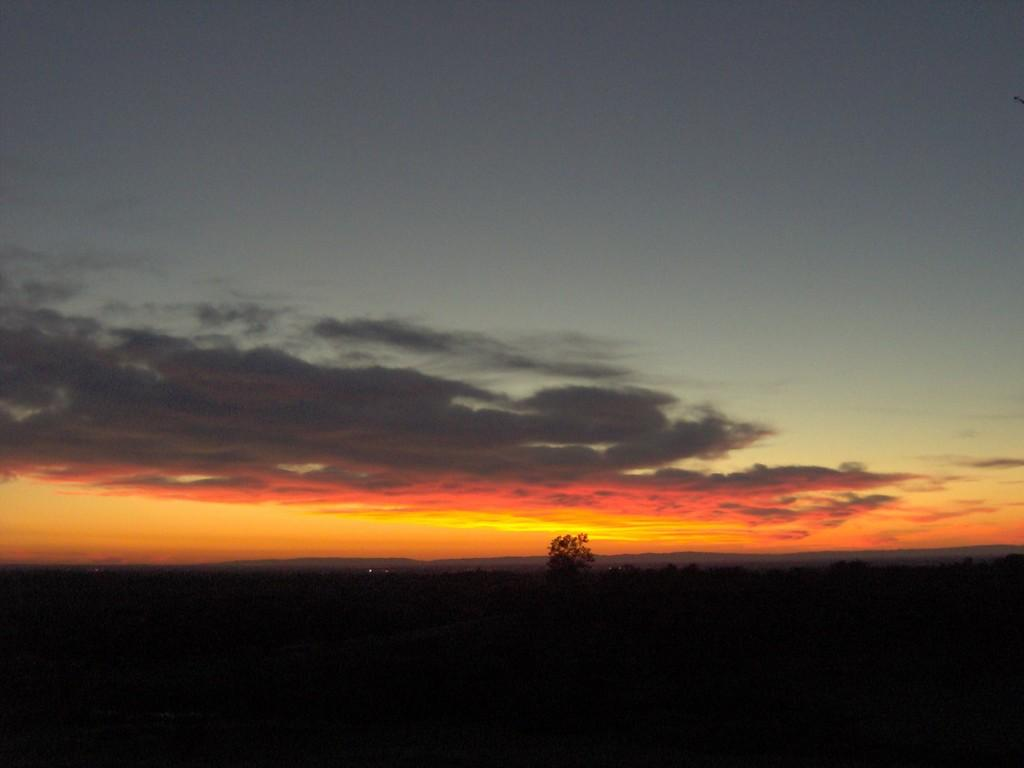What can be seen in the background of the image? The sky is visible in the image. What is the condition of the sky in the image? There are clouds in the sky. What type of vegetation is present in the image? There is a plant in the image. What type of plantation can be seen in the image? There is no plantation present in the image; it only features a single plant. What thoughts are being expressed by the plant in the image? Plants do not have the ability to express thoughts, so this cannot be determined from the image. 